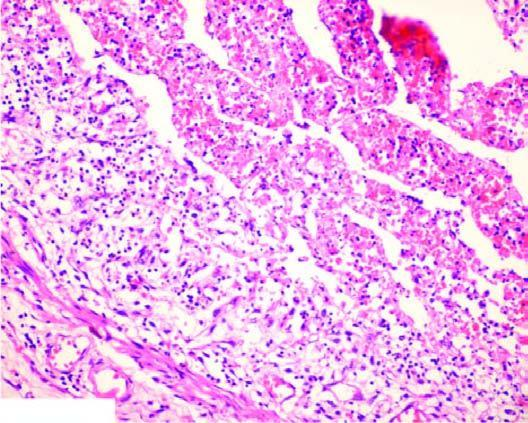s there acute panarteritis?
Answer the question using a single word or phrase. Yes 